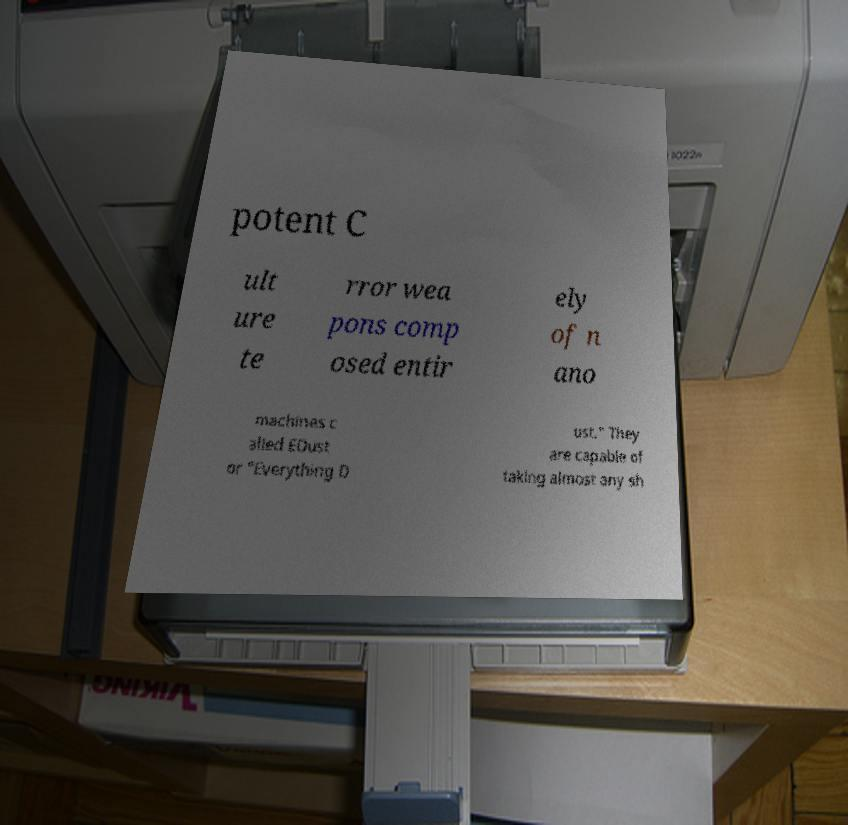I need the written content from this picture converted into text. Can you do that? potent C ult ure te rror wea pons comp osed entir ely of n ano machines c alled EDust or "Everything D ust." They are capable of taking almost any sh 